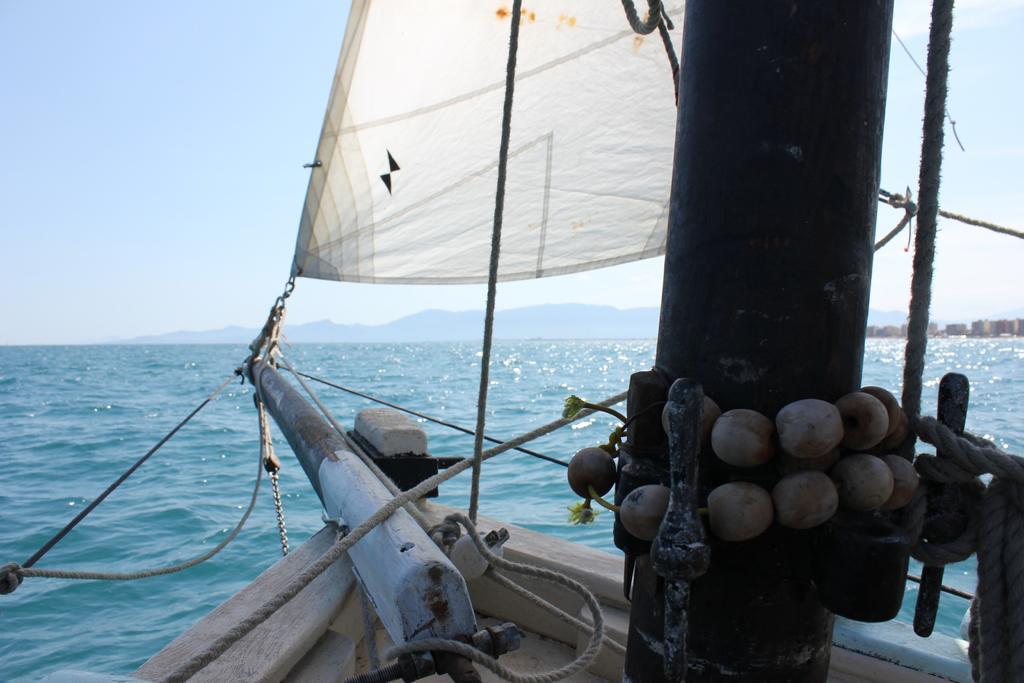Please provide a concise description of this image. In this image, we can see a boat on the water and in the background, there are hills and we can see buildings. 